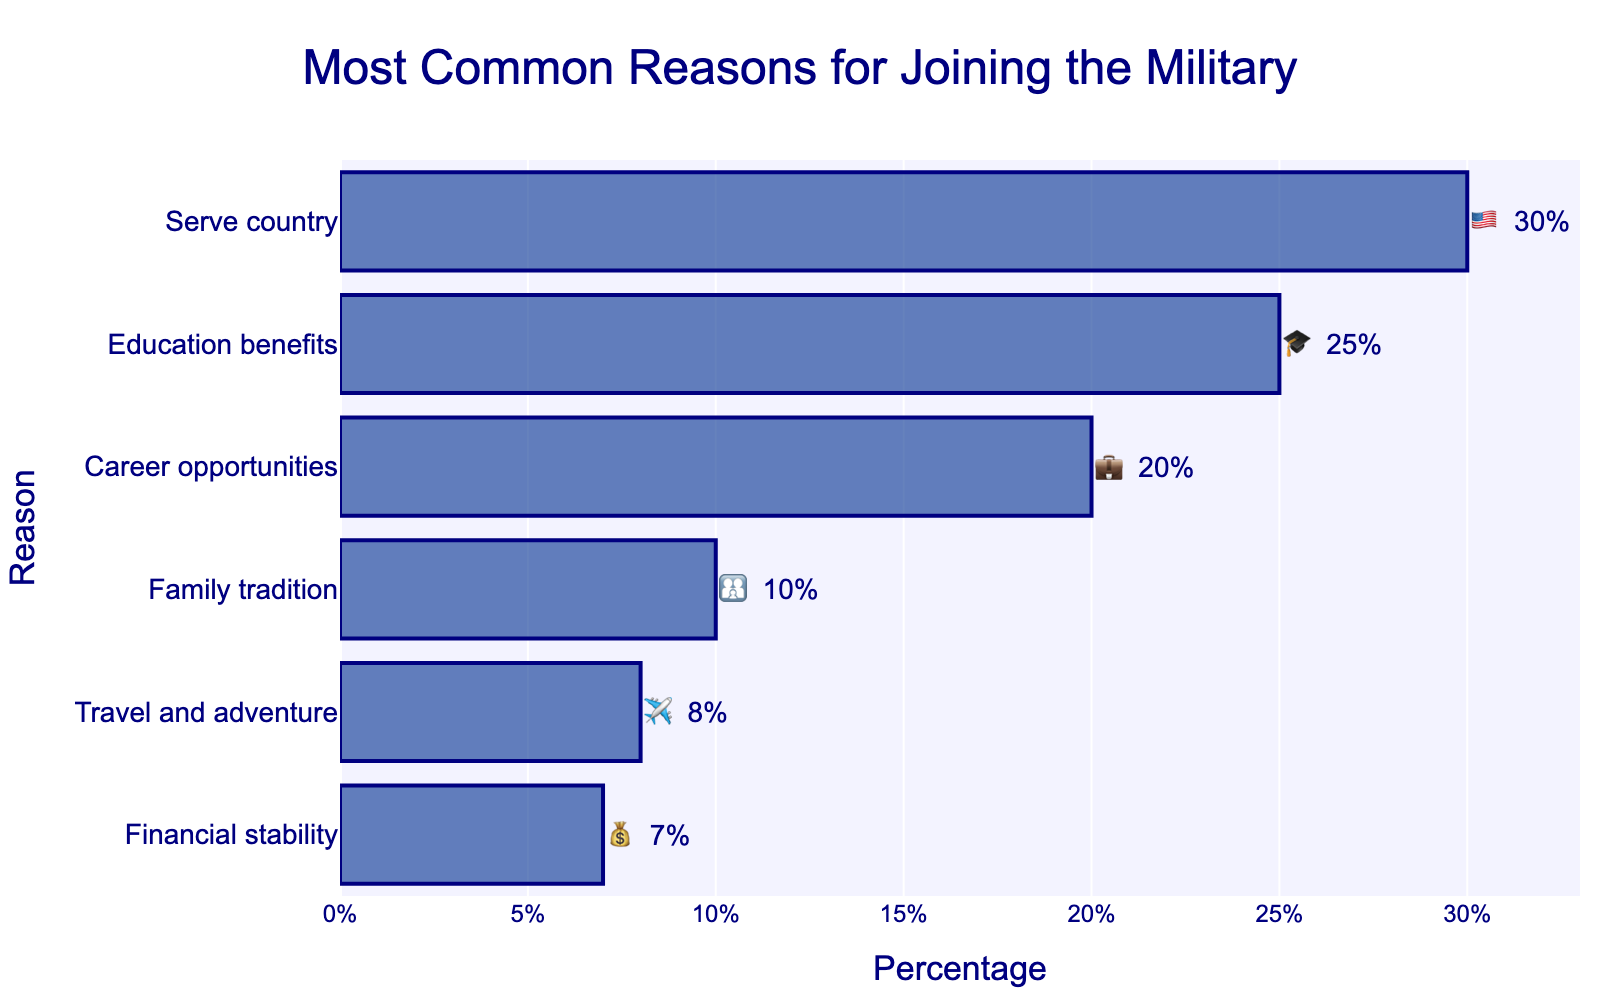What's the title of the figure? The title is placed at the top of the figure and it indicates the main subject of the chart.
Answer: Most Common Reasons for Joining the Military Which reason has the highest percentage? By looking at the length of the bars and their corresponding percentages, the longest bar represents the highest percentage.
Answer: Serve country How many reasons are represented in the chart? Each data point in the chart is a separate bar, so we count the number of bars.
Answer: 6 What is the combined percentage of reasons related to benefits (Education and Financial stability)? Add the percentages associated with Education benefits and Financial stability. 25% (Education benefits) + 7% (Financial stability) = 32%
Answer: 32% What is the difference in percentage between Career opportunities and Travel and adventure? Subtract the smaller percentage from the larger one. 20% (Career opportunities) - 8% (Travel and adventure) = 12%
Answer: 12% Which reason has the least percentage? By identifying the shortest bar and its corresponding percentage.
Answer: Financial stability What is the average percentage of family-related reasons (Family tradition and Financial stability)? Calculate the average by adding the percentages of Family tradition and Financial stability and then divide by 2. (10% + 7%) / 2 = 8.5%
Answer: 8.5% How does the percentage for Education benefits compare to Career opportunities? Compare the two values. Education benefits = 25%, Career opportunities = 20%. Education benefits have a higher percentage.
Answer: Education benefits have a higher percentage Which reasons have a percentage above 20%? Identify the bars whose percentage values are above 20%.
Answer: Serve country, Education benefits What percentage of respondents join the military for Travel and adventure? Directly refer to the value listed next to the Travel and adventure bar.
Answer: 8% 